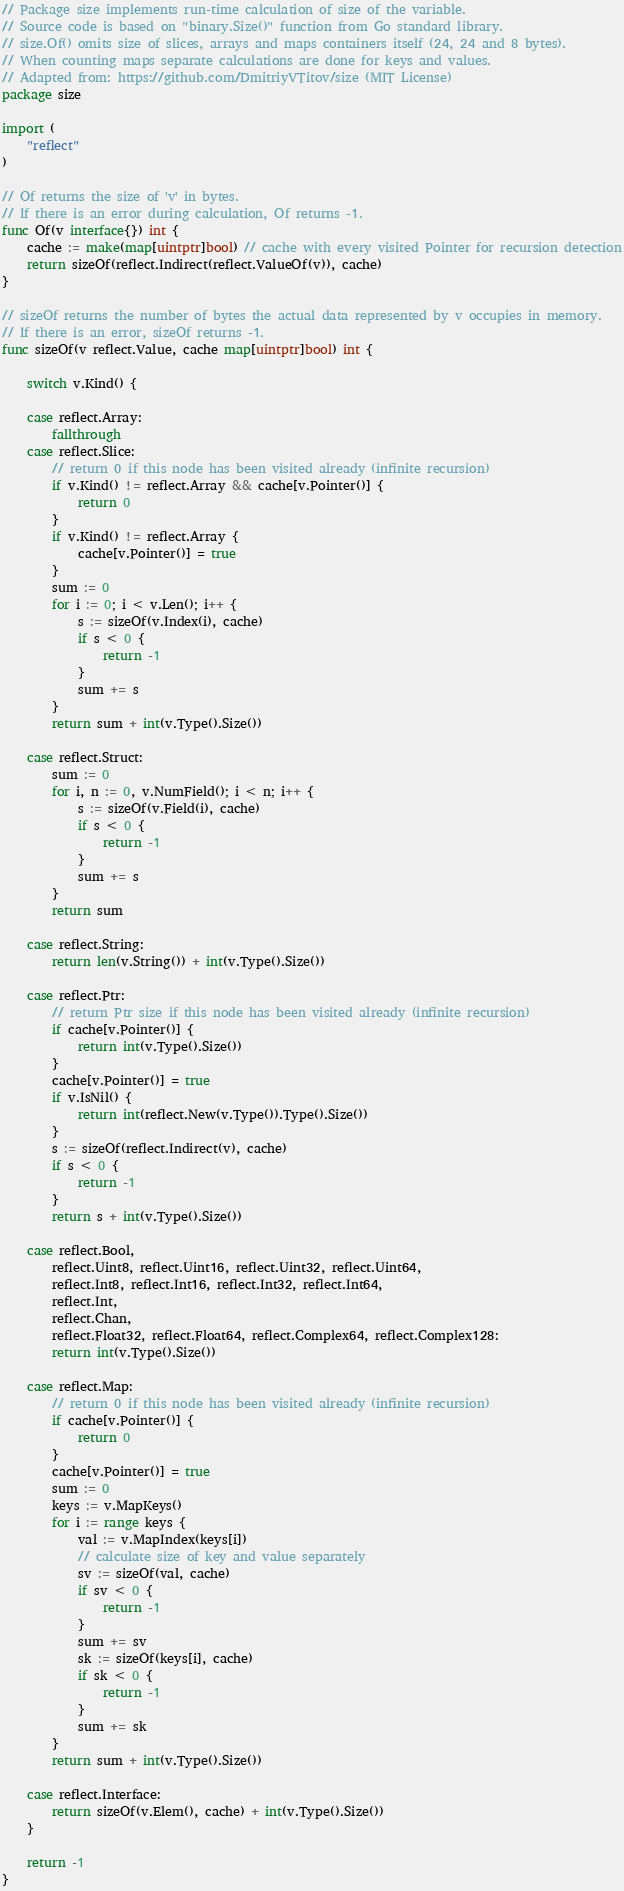Convert code to text. <code><loc_0><loc_0><loc_500><loc_500><_Go_>// Package size implements run-time calculation of size of the variable.
// Source code is based on "binary.Size()" function from Go standard library.
// size.Of() omits size of slices, arrays and maps containers itself (24, 24 and 8 bytes).
// When counting maps separate calculations are done for keys and values.
// Adapted from: https://github.com/DmitriyVTitov/size (MIT License)
package size

import (
	"reflect"
)

// Of returns the size of 'v' in bytes.
// If there is an error during calculation, Of returns -1.
func Of(v interface{}) int {
	cache := make(map[uintptr]bool) // cache with every visited Pointer for recursion detection
	return sizeOf(reflect.Indirect(reflect.ValueOf(v)), cache)
}

// sizeOf returns the number of bytes the actual data represented by v occupies in memory.
// If there is an error, sizeOf returns -1.
func sizeOf(v reflect.Value, cache map[uintptr]bool) int {

	switch v.Kind() {

	case reflect.Array:
		fallthrough
	case reflect.Slice:
		// return 0 if this node has been visited already (infinite recursion)
		if v.Kind() != reflect.Array && cache[v.Pointer()] {
			return 0
		}
		if v.Kind() != reflect.Array {
			cache[v.Pointer()] = true
		}
		sum := 0
		for i := 0; i < v.Len(); i++ {
			s := sizeOf(v.Index(i), cache)
			if s < 0 {
				return -1
			}
			sum += s
		}
		return sum + int(v.Type().Size())

	case reflect.Struct:
		sum := 0
		for i, n := 0, v.NumField(); i < n; i++ {
			s := sizeOf(v.Field(i), cache)
			if s < 0 {
				return -1
			}
			sum += s
		}
		return sum

	case reflect.String:
		return len(v.String()) + int(v.Type().Size())

	case reflect.Ptr:
		// return Ptr size if this node has been visited already (infinite recursion)
		if cache[v.Pointer()] {
			return int(v.Type().Size())
		}
		cache[v.Pointer()] = true
		if v.IsNil() {
			return int(reflect.New(v.Type()).Type().Size())
		}
		s := sizeOf(reflect.Indirect(v), cache)
		if s < 0 {
			return -1
		}
		return s + int(v.Type().Size())

	case reflect.Bool,
		reflect.Uint8, reflect.Uint16, reflect.Uint32, reflect.Uint64,
		reflect.Int8, reflect.Int16, reflect.Int32, reflect.Int64,
		reflect.Int,
		reflect.Chan,
		reflect.Float32, reflect.Float64, reflect.Complex64, reflect.Complex128:
		return int(v.Type().Size())

	case reflect.Map:
		// return 0 if this node has been visited already (infinite recursion)
		if cache[v.Pointer()] {
			return 0
		}
		cache[v.Pointer()] = true
		sum := 0
		keys := v.MapKeys()
		for i := range keys {
			val := v.MapIndex(keys[i])
			// calculate size of key and value separately
			sv := sizeOf(val, cache)
			if sv < 0 {
				return -1
			}
			sum += sv
			sk := sizeOf(keys[i], cache)
			if sk < 0 {
				return -1
			}
			sum += sk
		}
		return sum + int(v.Type().Size())

	case reflect.Interface:
		return sizeOf(v.Elem(), cache) + int(v.Type().Size())
	}

	return -1
}
</code> 